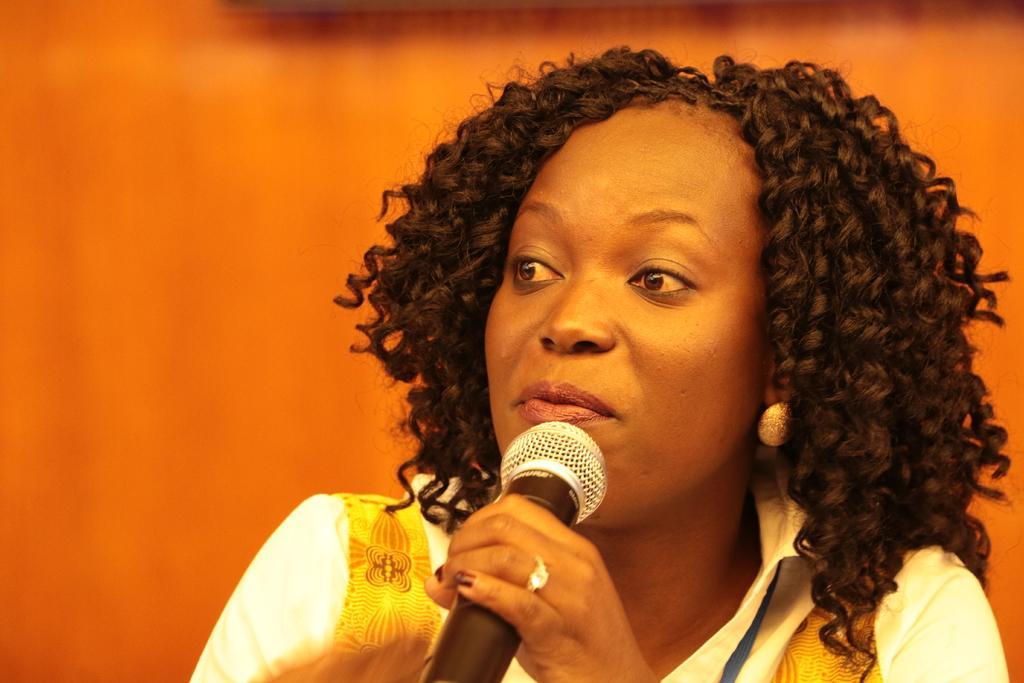In one or two sentences, can you explain what this image depicts? I can see in this image the woman is holding a microphone in her hand. The woman is wearing a white color dress 